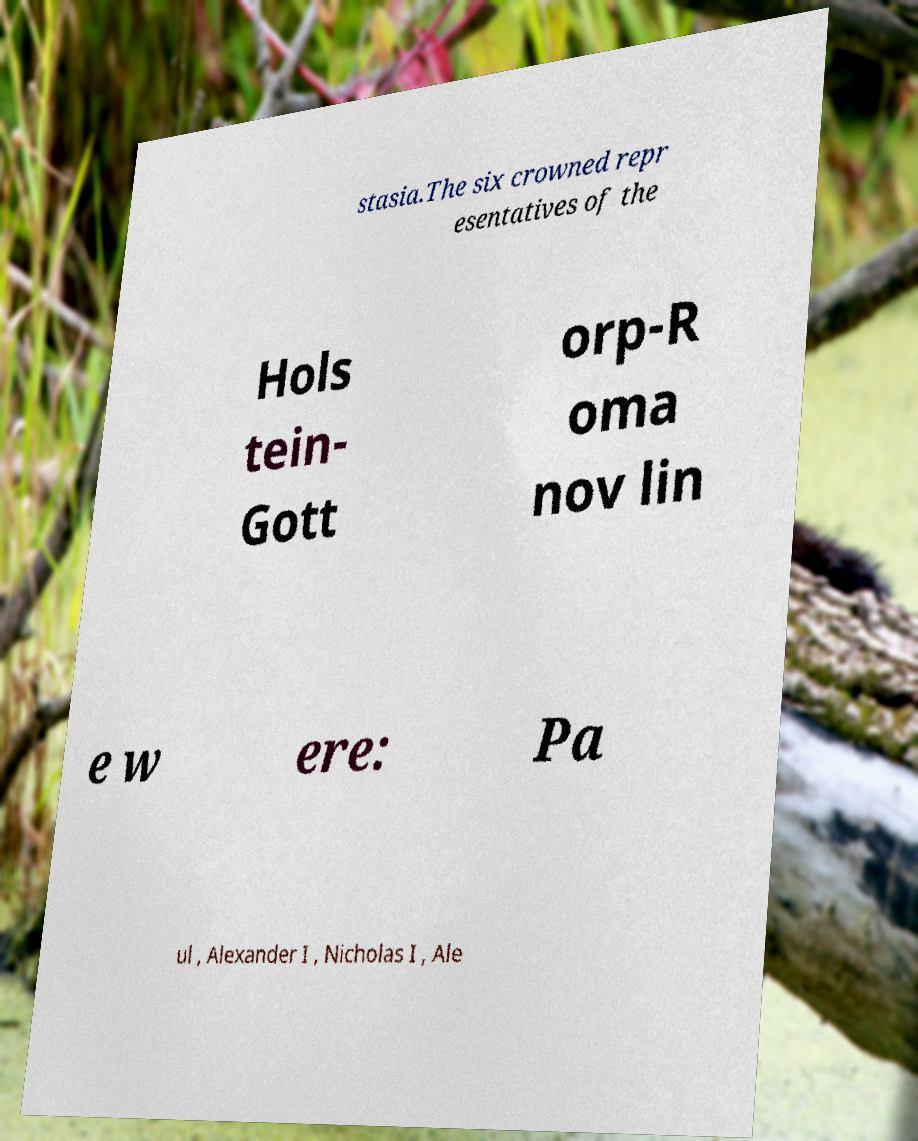Can you accurately transcribe the text from the provided image for me? stasia.The six crowned repr esentatives of the Hols tein- Gott orp-R oma nov lin e w ere: Pa ul , Alexander I , Nicholas I , Ale 